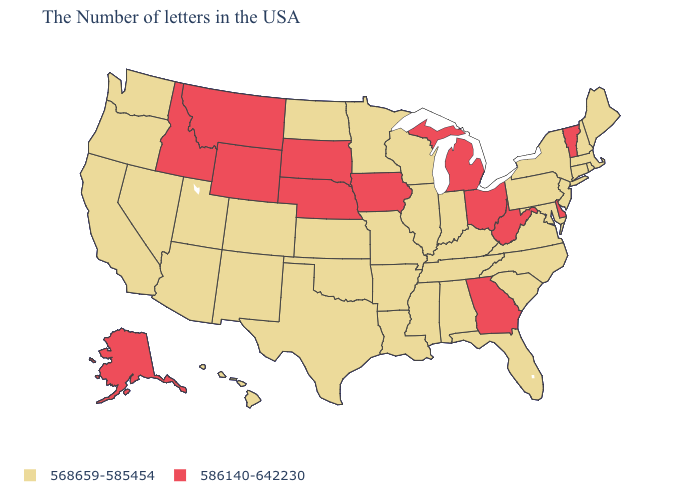Name the states that have a value in the range 586140-642230?
Be succinct. Vermont, Delaware, West Virginia, Ohio, Georgia, Michigan, Iowa, Nebraska, South Dakota, Wyoming, Montana, Idaho, Alaska. Which states hav the highest value in the South?
Keep it brief. Delaware, West Virginia, Georgia. What is the lowest value in the MidWest?
Be succinct. 568659-585454. Among the states that border Oregon , which have the highest value?
Give a very brief answer. Idaho. Is the legend a continuous bar?
Concise answer only. No. What is the value of Mississippi?
Be succinct. 568659-585454. What is the lowest value in the USA?
Concise answer only. 568659-585454. Among the states that border Pennsylvania , which have the lowest value?
Answer briefly. New York, New Jersey, Maryland. Which states have the highest value in the USA?
Answer briefly. Vermont, Delaware, West Virginia, Ohio, Georgia, Michigan, Iowa, Nebraska, South Dakota, Wyoming, Montana, Idaho, Alaska. Does New Hampshire have a lower value than Iowa?
Be succinct. Yes. What is the value of New Hampshire?
Be succinct. 568659-585454. Among the states that border Minnesota , does North Dakota have the lowest value?
Give a very brief answer. Yes. What is the lowest value in the Northeast?
Answer briefly. 568659-585454. Which states have the lowest value in the USA?
Answer briefly. Maine, Massachusetts, Rhode Island, New Hampshire, Connecticut, New York, New Jersey, Maryland, Pennsylvania, Virginia, North Carolina, South Carolina, Florida, Kentucky, Indiana, Alabama, Tennessee, Wisconsin, Illinois, Mississippi, Louisiana, Missouri, Arkansas, Minnesota, Kansas, Oklahoma, Texas, North Dakota, Colorado, New Mexico, Utah, Arizona, Nevada, California, Washington, Oregon, Hawaii. What is the highest value in the MidWest ?
Write a very short answer. 586140-642230. 